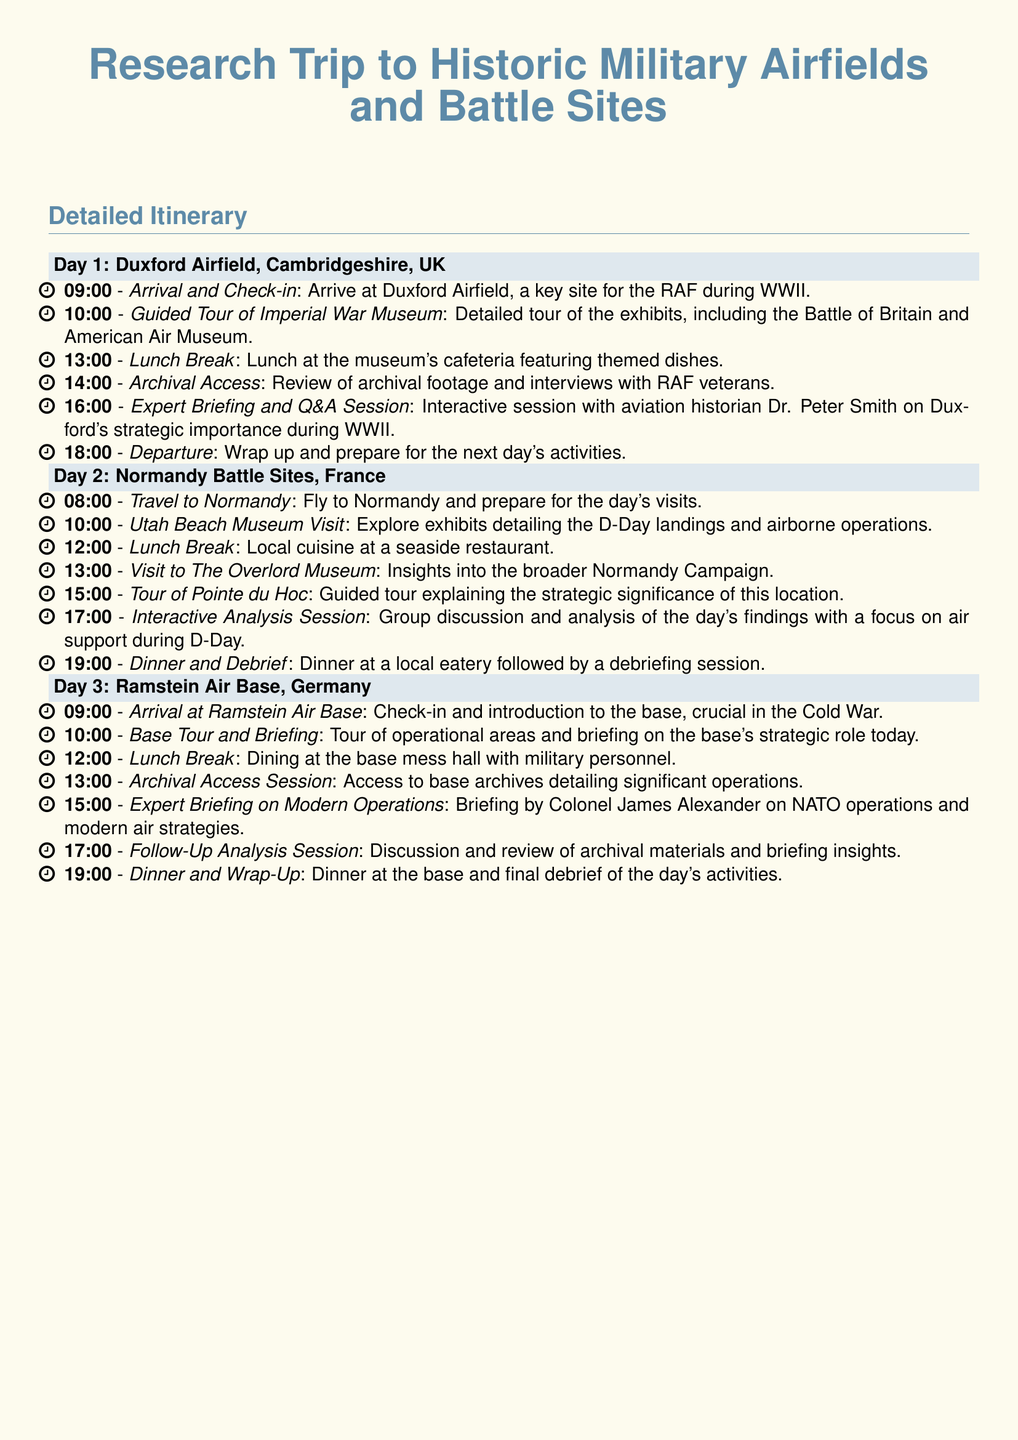What is the first location in the itinerary? The first location is mentioned in the document's header for Day 1, indicating where the activities take place.
Answer: Duxford Airfield, Cambridgeshire, UK How many days are included in the research trip? The document outlines activities over three distinct days, each with its own header.
Answer: 3 Who is the historian providing the briefing at Duxford? The document specifically names the historian leading the briefing for the first site, which indicates expertise in the area.
Answer: Dr. Peter Smith What time does the tour of Pointe du Hoc start? This time can be found in the schedule detailing the sequence of events for Day 2 in Normandy.
Answer: 15:00 What is a focus of the interactive analysis session in Normandy? The content of the day's findings is summarized in the document, pointing out the main topic of discussion during the session.
Answer: Air support during D-Day What is the final activity on Day 3? The last task on the third day is listed clearly in the itinerary, demonstrating the conclusion of the day's events.
Answer: Dinner and Wrap-Up At what time does lunch take place at Ramstein Air Base? The document specifies the scheduled time for lunch during Day 3 activities.
Answer: 12:00 What type of cuisine is available during the lunch break in Normandy? The document provides specific details about the dining experience including local culture and food.
Answer: Local cuisine 